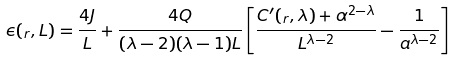Convert formula to latex. <formula><loc_0><loc_0><loc_500><loc_500>\epsilon ( _ { r } , L ) = \frac { 4 J } { L } + \frac { 4 Q } { ( \lambda - 2 ) ( \lambda - 1 ) L } \left [ \frac { C ^ { \prime } ( _ { r } , \lambda ) + \alpha ^ { 2 - \lambda } } { L ^ { \lambda - 2 } } - \frac { 1 } { a ^ { \lambda - 2 } } \right ]</formula> 